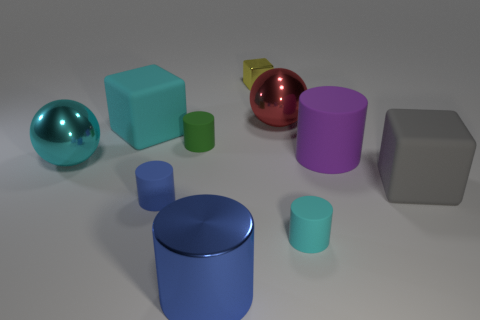How many objects are there in total? In this visually captivating arrangement, one can count a total of eight objects, each boasting unique colors and geometric shapes. 